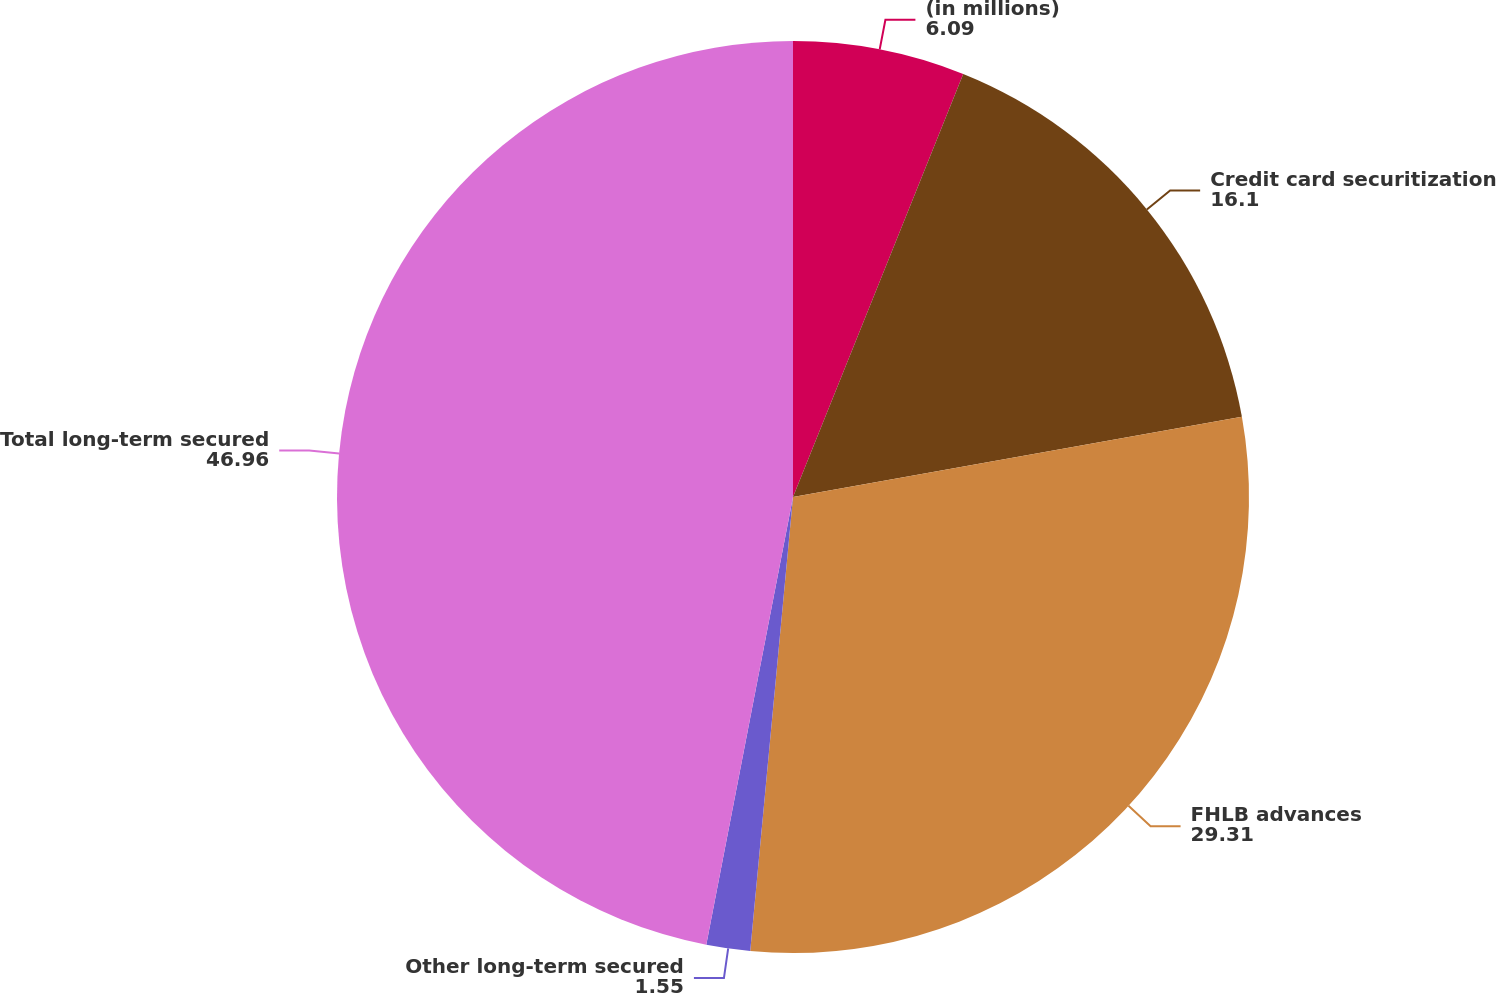Convert chart. <chart><loc_0><loc_0><loc_500><loc_500><pie_chart><fcel>(in millions)<fcel>Credit card securitization<fcel>FHLB advances<fcel>Other long-term secured<fcel>Total long-term secured<nl><fcel>6.09%<fcel>16.1%<fcel>29.31%<fcel>1.55%<fcel>46.96%<nl></chart> 